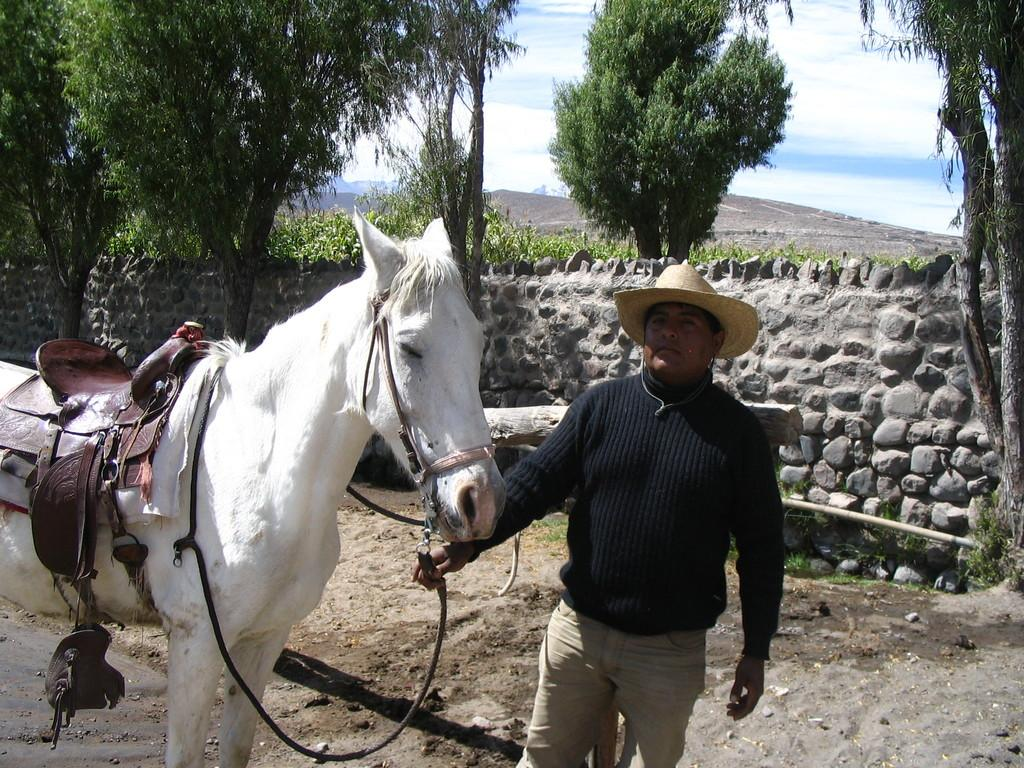What is the main subject of the image? The main subject of the image is a man. Can you describe what the man is wearing? The man is wearing a black sweatshirt and a hat. What is the man holding in the image? The man is holding a white horse. What can be seen in the background of the image? There is a fence in the background of the image, with trees on either side and the sky visible above. What is the condition of the sky in the image? The sky is visible above the fence, and clouds are present in the sky. What type of news can be heard coming from the radio in the image? There is no radio present in the image, so it's not possible to determine what news might be heard. What type of cord is attached to the man's suit in the image? There is no suit or cord present in the image; the man is wearing a black sweatshirt and a hat. 